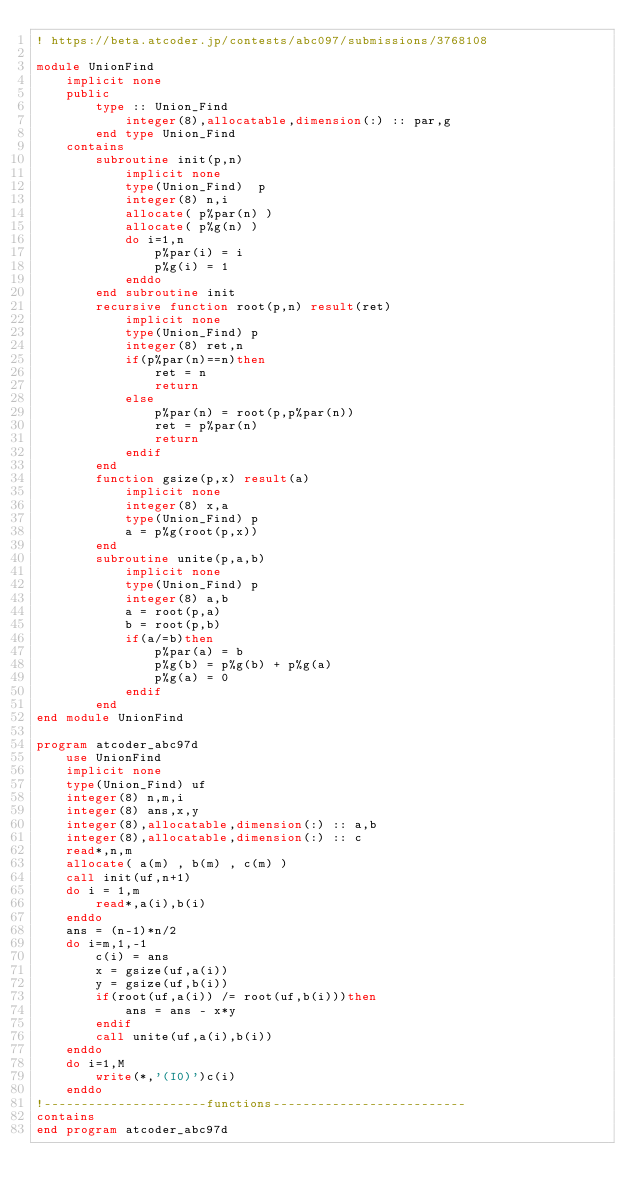<code> <loc_0><loc_0><loc_500><loc_500><_FORTRAN_>! https://beta.atcoder.jp/contests/abc097/submissions/3768108

module UnionFind
    implicit none
    public
        type :: Union_Find
            integer(8),allocatable,dimension(:) :: par,g
        end type Union_Find
    contains
        subroutine init(p,n)
            implicit none
            type(Union_Find)  p
            integer(8) n,i
            allocate( p%par(n) )
            allocate( p%g(n) )
            do i=1,n
                p%par(i) = i
                p%g(i) = 1
            enddo
        end subroutine init
        recursive function root(p,n) result(ret)
            implicit none
            type(Union_Find) p
            integer(8) ret,n
            if(p%par(n)==n)then
                ret = n
                return
            else
                p%par(n) = root(p,p%par(n))
                ret = p%par(n)
                return
            endif
        end
        function gsize(p,x) result(a)
            implicit none
            integer(8) x,a
            type(Union_Find) p
            a = p%g(root(p,x))
        end
        subroutine unite(p,a,b)
            implicit none
            type(Union_Find) p
            integer(8) a,b
            a = root(p,a)
            b = root(p,b)
            if(a/=b)then
                p%par(a) = b
                p%g(b) = p%g(b) + p%g(a)
                p%g(a) = 0
            endif
        end
end module UnionFind

program atcoder_abc97d
    use UnionFind
    implicit none
    type(Union_Find) uf
    integer(8) n,m,i
    integer(8) ans,x,y
    integer(8),allocatable,dimension(:) :: a,b
    integer(8),allocatable,dimension(:) :: c
    read*,n,m
    allocate( a(m) , b(m) , c(m) )
    call init(uf,n+1)
    do i = 1,m
        read*,a(i),b(i)
    enddo
    ans = (n-1)*n/2
    do i=m,1,-1
        c(i) = ans
        x = gsize(uf,a(i))
        y = gsize(uf,b(i))
        if(root(uf,a(i)) /= root(uf,b(i)))then
            ans = ans - x*y
        endif
        call unite(uf,a(i),b(i))
    enddo
    do i=1,M
        write(*,'(I0)')c(i)
    enddo
!----------------------functions--------------------------
contains
end program atcoder_abc97d</code> 